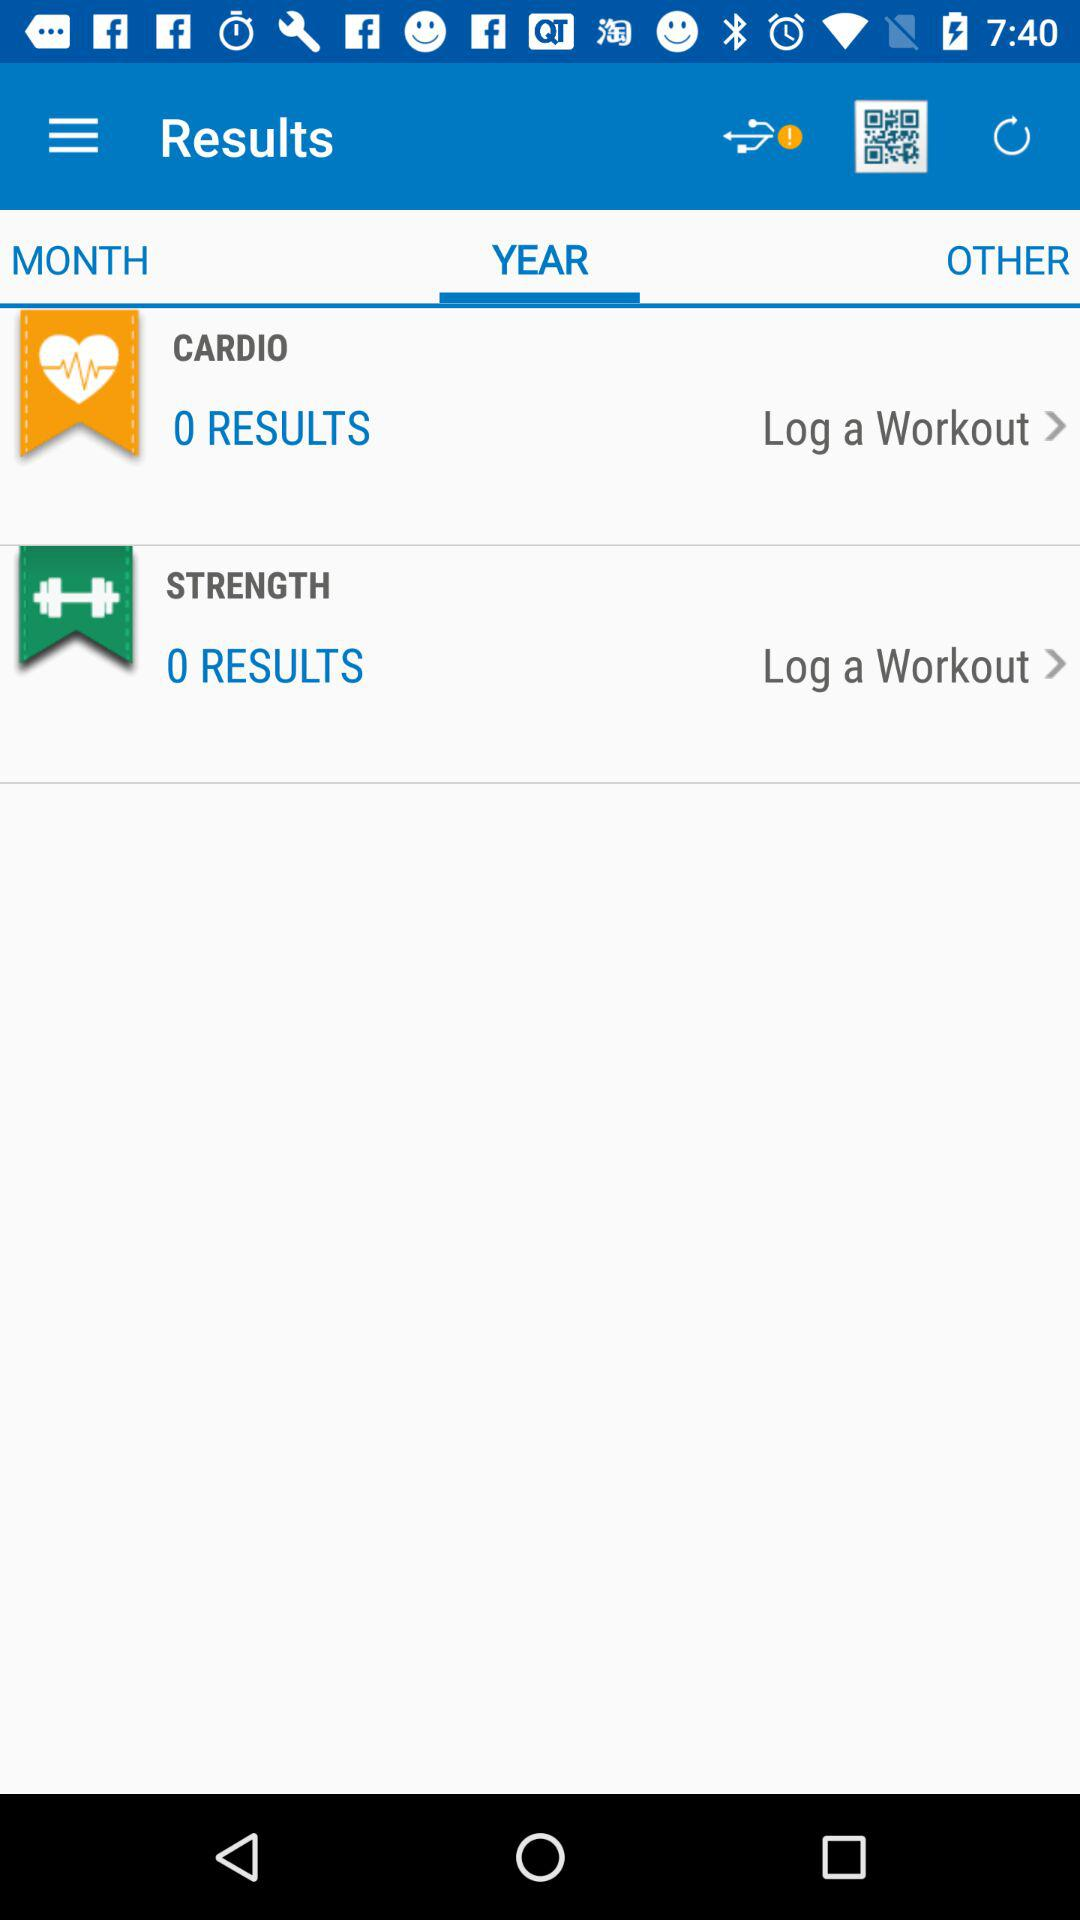How many results are there in "CARDIO"? There are 0 results in "CARDIO". 